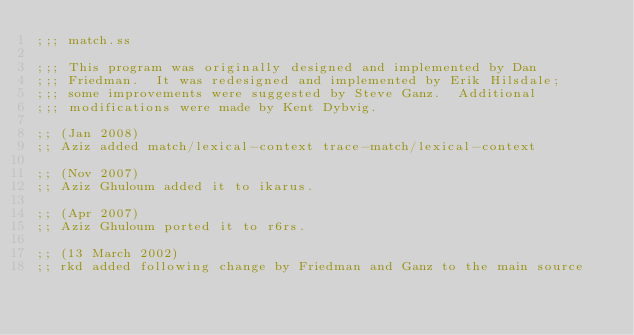Convert code to text. <code><loc_0><loc_0><loc_500><loc_500><_Scheme_>;;; match.ss

;;; This program was originally designed and implemented by Dan
;;; Friedman.  It was redesigned and implemented by Erik Hilsdale;
;;; some improvements were suggested by Steve Ganz.  Additional
;;; modifications were made by Kent Dybvig.

;; (Jan 2008)
;; Aziz added match/lexical-context trace-match/lexical-context

;; (Nov 2007)
;; Aziz Ghuloum added it to ikarus.

;; (Apr 2007)
;; Aziz Ghuloum ported it to r6rs.

;; (13 March 2002)
;; rkd added following change by Friedman and Ganz to the main source</code> 